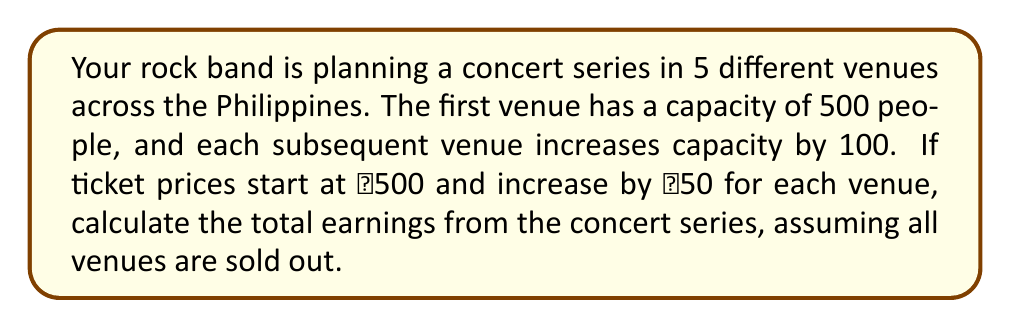Provide a solution to this math problem. Let's approach this step-by-step:

1) First, let's define our sequences:
   Venue capacities: $a_n = 500 + 100(n-1)$, where $n$ is the venue number
   Ticket prices: $p_n = 500 + 50(n-1)$

2) Now, we need to calculate the earnings for each venue and sum them up:
   Earnings = $\sum_{n=1}^5 a_n \cdot p_n$

3) Let's expand this:
   $E = (500 \cdot 500) + (600 \cdot 550) + (700 \cdot 600) + (800 \cdot 650) + (900 \cdot 700)$

4) Calculate each term:
   $E = 250,000 + 330,000 + 420,000 + 520,000 + 630,000$

5) Sum up:
   $E = 2,150,000$

Therefore, the total earnings from the concert series is ₱2,150,000.
Answer: ₱2,150,000 